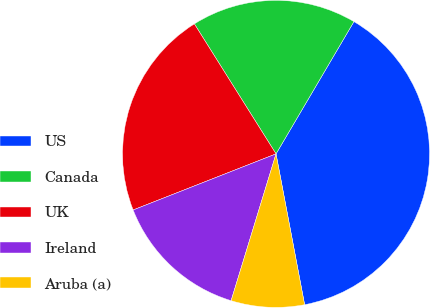<chart> <loc_0><loc_0><loc_500><loc_500><pie_chart><fcel>US<fcel>Canada<fcel>UK<fcel>Ireland<fcel>Aruba (a)<nl><fcel>38.55%<fcel>17.4%<fcel>22.03%<fcel>14.32%<fcel>7.71%<nl></chart> 